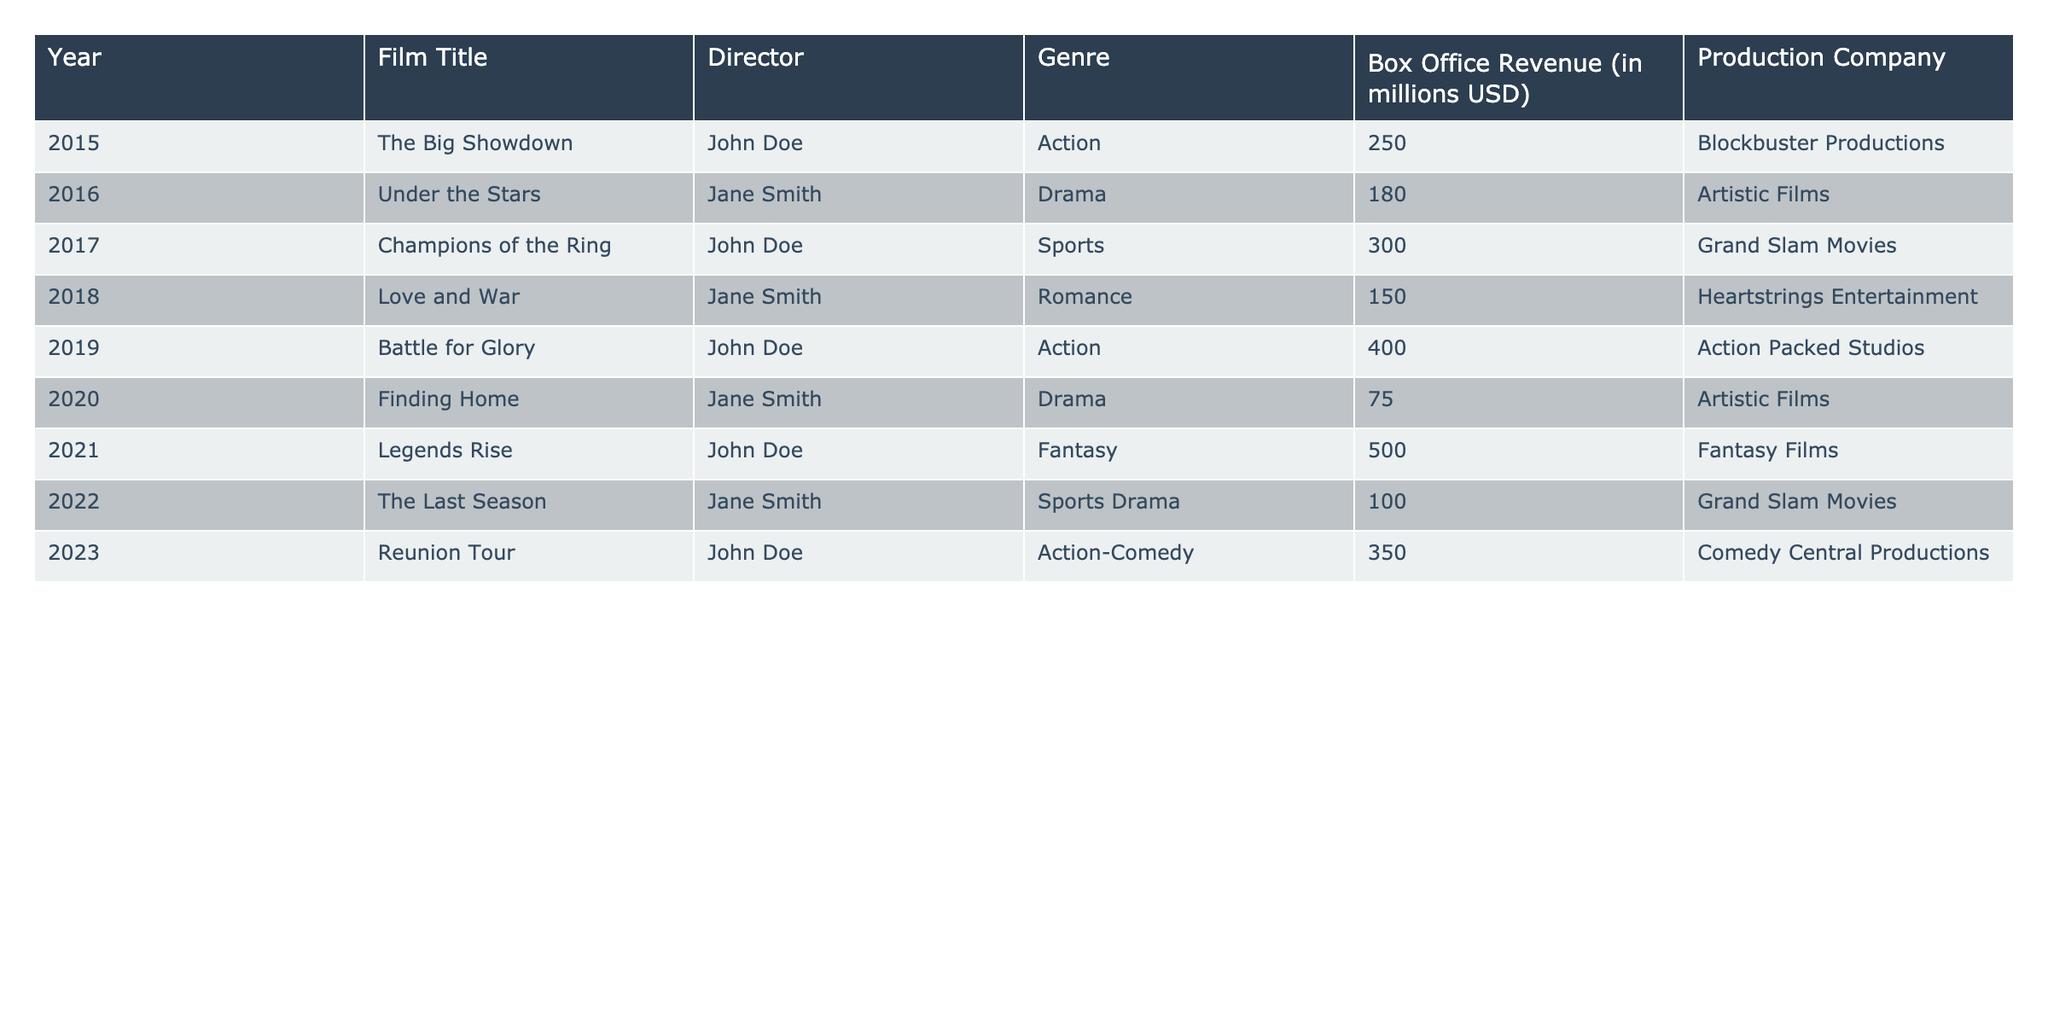What is the total box office revenue for films directed by John Doe? To find the total revenue for John Doe’s films, look at the box office revenues of "The Big Showdown," "Champions of the Ring," "Battle for Glory," "Legends Rise," and "Reunion Tour." Adding these together gives 250 + 300 + 400 + 500 + 350 = 1800 million USD.
Answer: 1800 million USD Which film had the highest box office revenue in 2021? The film "Legends Rise," directed by John Doe, had the highest box office revenue in 2021, which is 500 million USD.
Answer: Legends Rise How many films in the table were directed by Jane Smith? From the table, Jane Smith directed three films: "Under the Stars," "Love and War," and "Finding Home."
Answer: 3 What is the average box office revenue for all films in the table? To calculate the average, first sum the box office revenues: 250 + 180 + 300 + 150 + 400 + 75 + 500 + 100 + 350 = 2005 million USD. Then, divide by the number of films (9): 2005 / 9 ≈ 222.78 million USD.
Answer: 222.78 million USD Which genre had the highest total box office revenue? First, sum the revenues by genre: Action (250 + 400 + 500 + 350 = 1500), Drama (180 + 75 = 255), Sports (300 + 100 = 400), Romance (150), and Fantasy (500). The highest is Action with 1500 million USD.
Answer: Action Were there any films that made less than 100 million USD? Yes, the films "Finding Home" (75 million) and "The Last Season" (100 million) made less than 100 million USD.
Answer: Yes Which director had the most films with a box office revenue above 300 million USD? John Doe directed three films with revenues above 300 million USD ("Champions of the Ring," "Battle for Glory," and "Legends Rise"), while Jane Smith had none.
Answer: John Doe What is the revenue difference between the highest-grossing film and the lowest-grossing film? The highest-grossing film is "Legends Rise" with 500 million USD, and the lowest is "Finding Home" with 75 million USD. The difference is 500 - 75 = 425 million USD.
Answer: 425 million USD Is there a film that made exactly 100 million USD? Yes, "The Last Season" made exactly 100 million USD.
Answer: Yes How many different genres are represented in this table? The genres represented are Action, Drama, Sports, Romance, and Fantasy, making a total of 5 different genres.
Answer: 5 